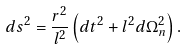Convert formula to latex. <formula><loc_0><loc_0><loc_500><loc_500>d s ^ { 2 } = \frac { r ^ { 2 } } { l ^ { 2 } } \left ( d t ^ { 2 } + l ^ { 2 } d \Omega _ { n } ^ { 2 } \right ) .</formula> 